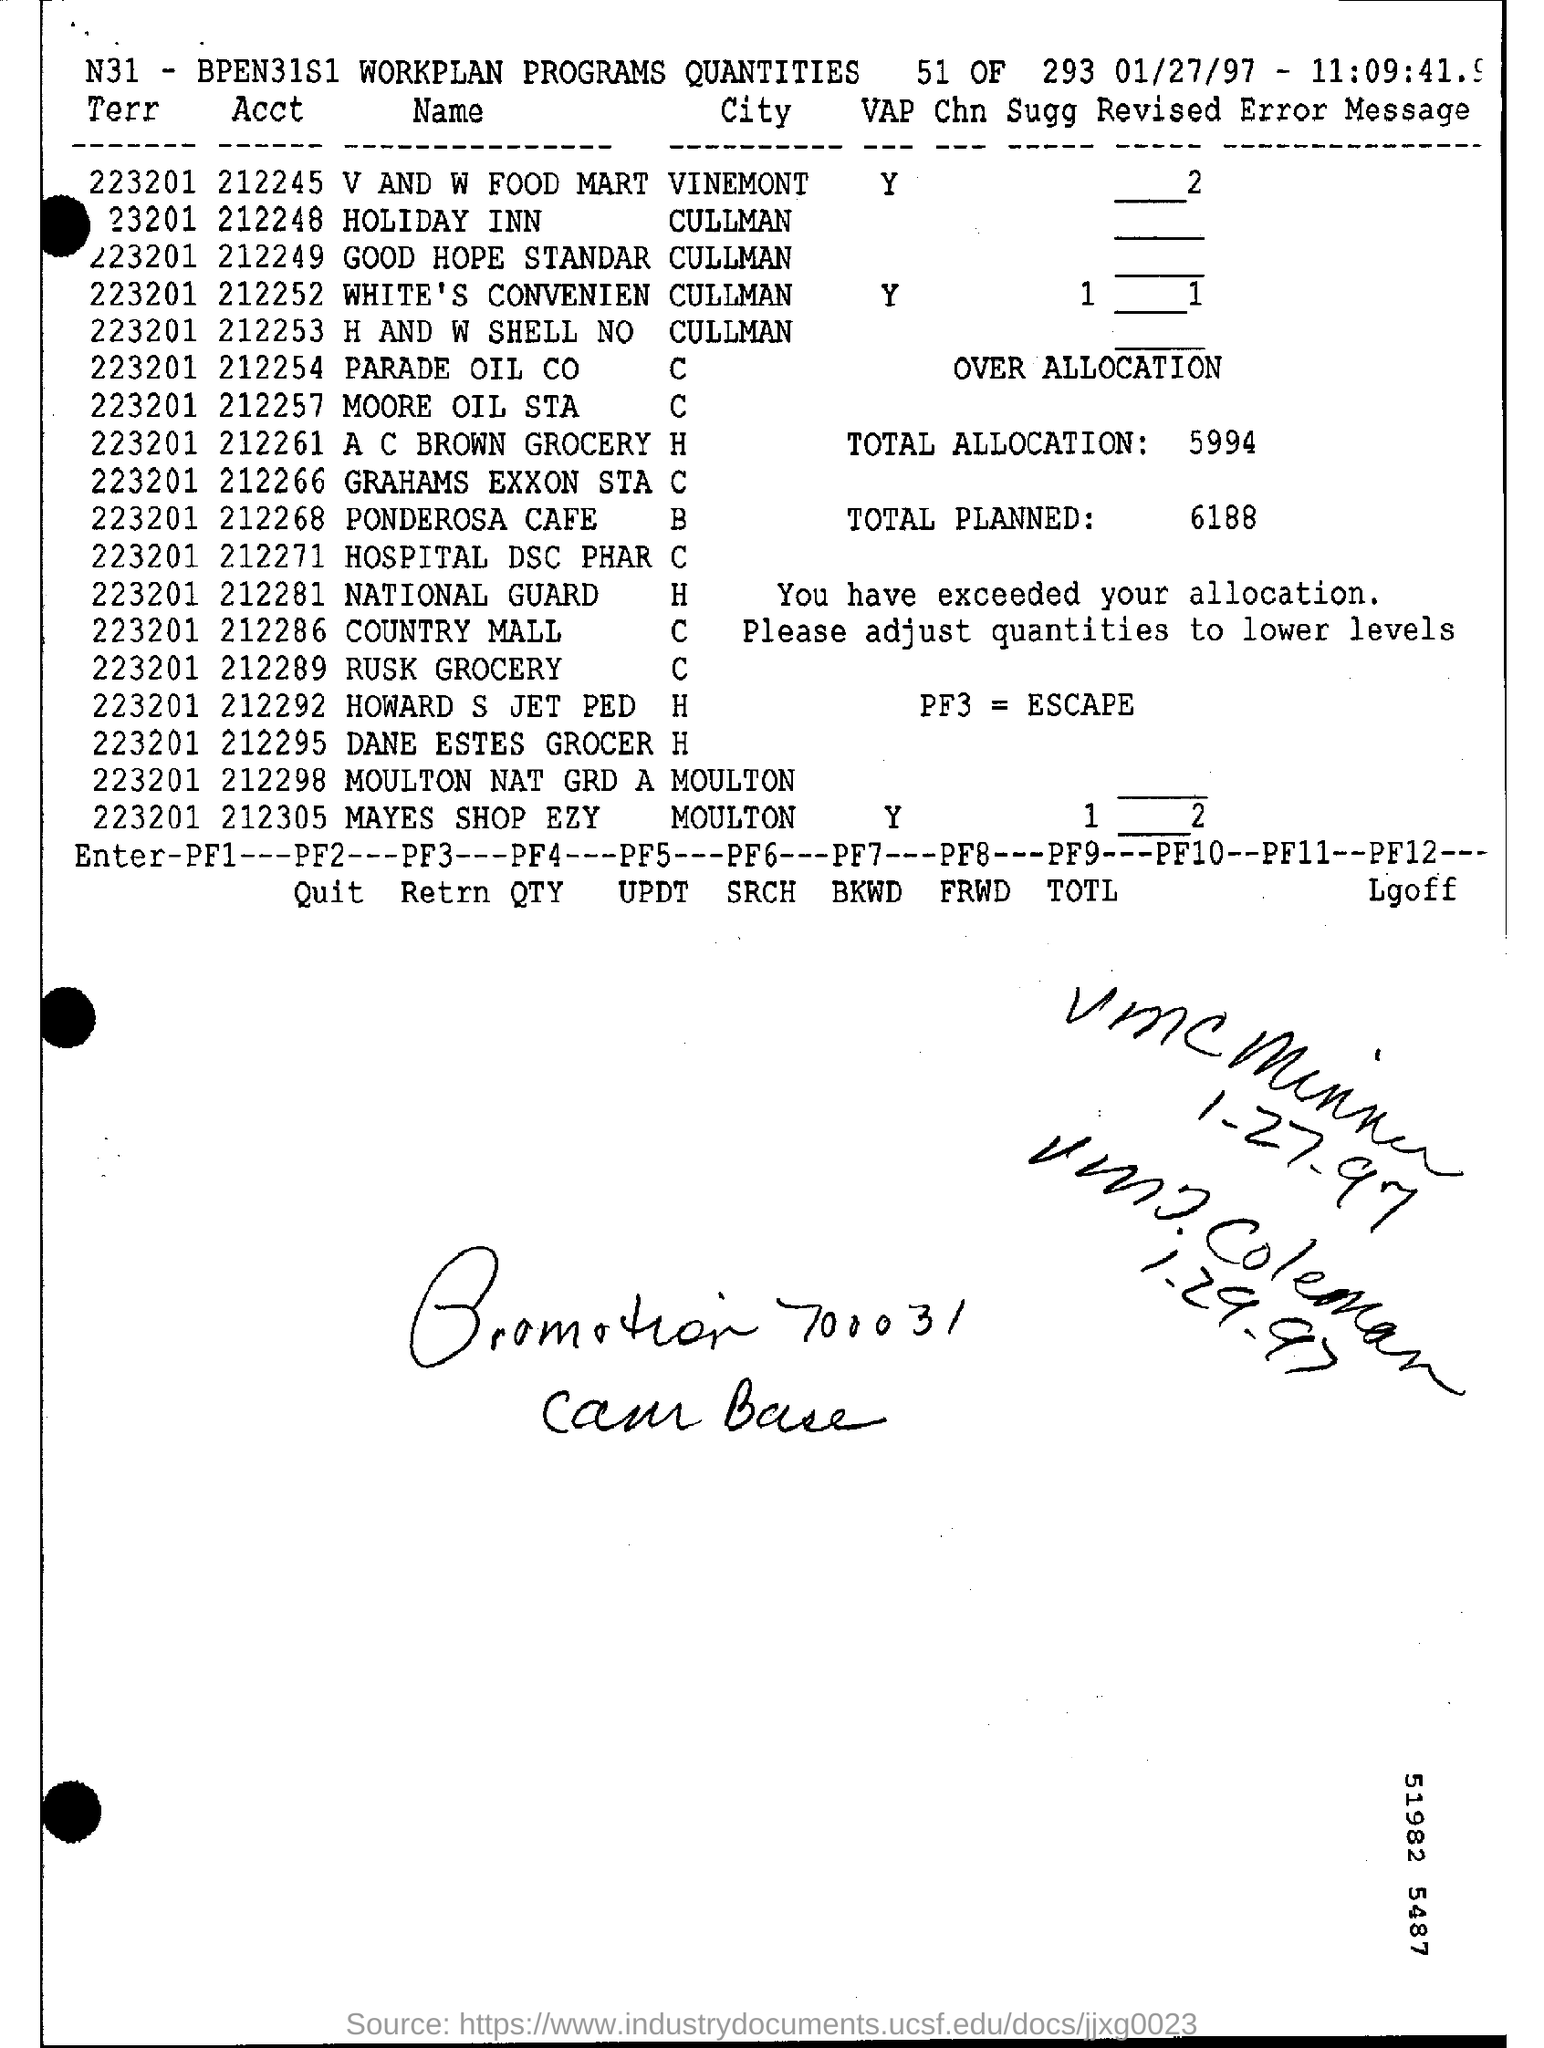List a handful of essential elements in this visual. What is PF3? It is an escape game that requires players to solve puzzles and escape from different themed rooms. The total allocation is 5,994. The total planned is 6188. V and W Food Mart is located in the city of Vinemont. A mention of the date, located in the top right corner of the page, was observed on January 27, 1997. 